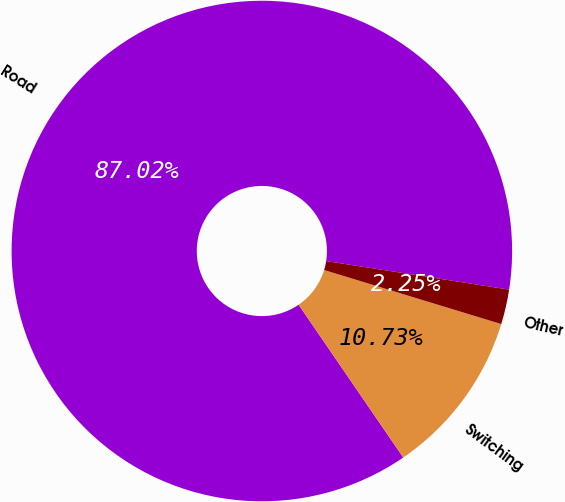<chart> <loc_0><loc_0><loc_500><loc_500><pie_chart><fcel>Road<fcel>Switching<fcel>Other<nl><fcel>87.02%<fcel>10.73%<fcel>2.25%<nl></chart> 